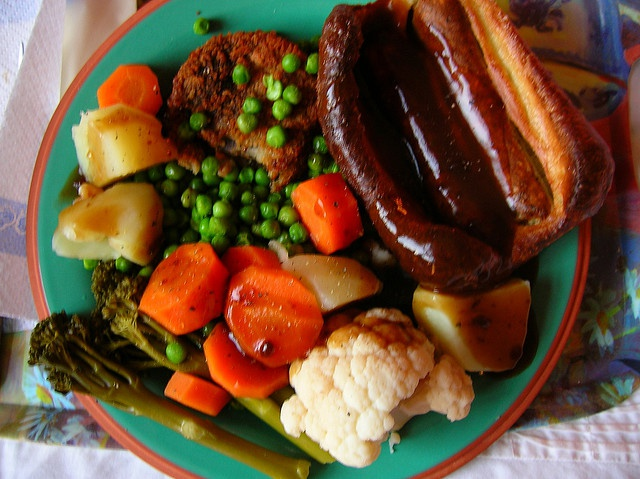Describe the objects in this image and their specific colors. I can see dining table in black, maroon, lavender, and brown tones, hot dog in lavender, black, maroon, and brown tones, sandwich in lavender, black, maroon, and olive tones, broccoli in lavender, black, olive, and maroon tones, and carrot in lavender, red, brown, and maroon tones in this image. 